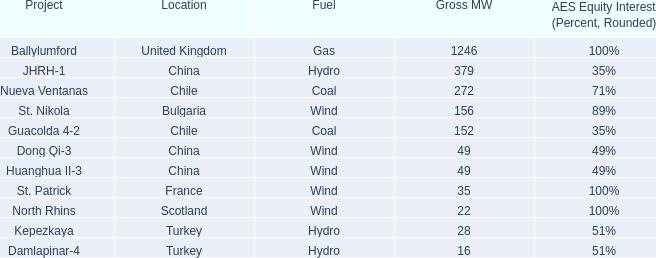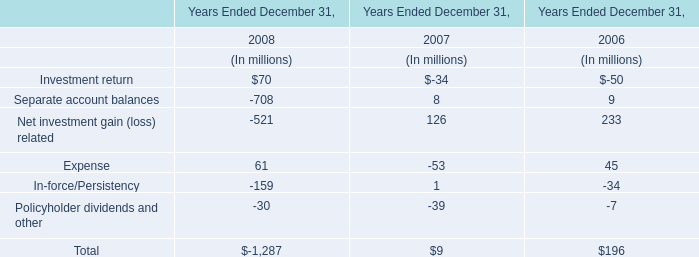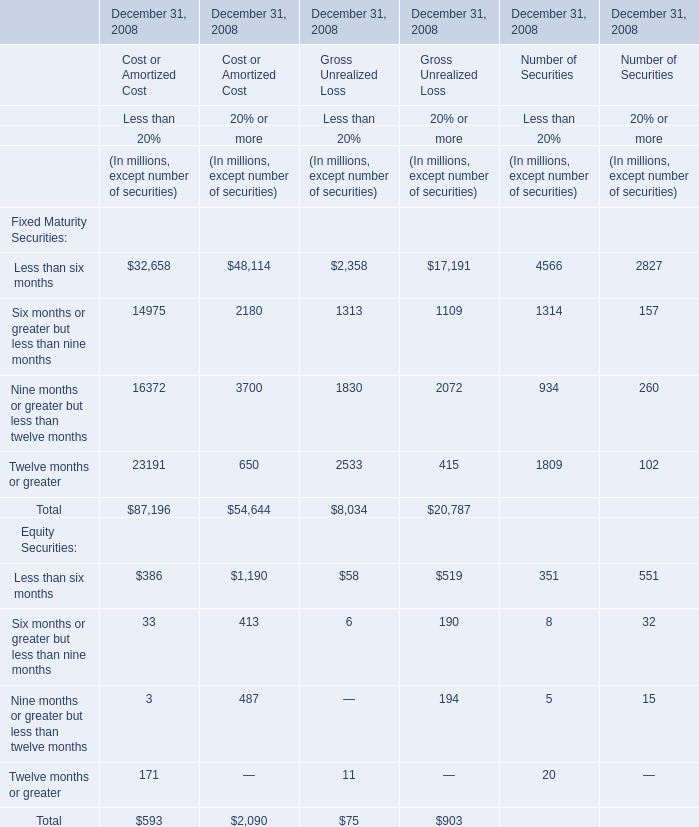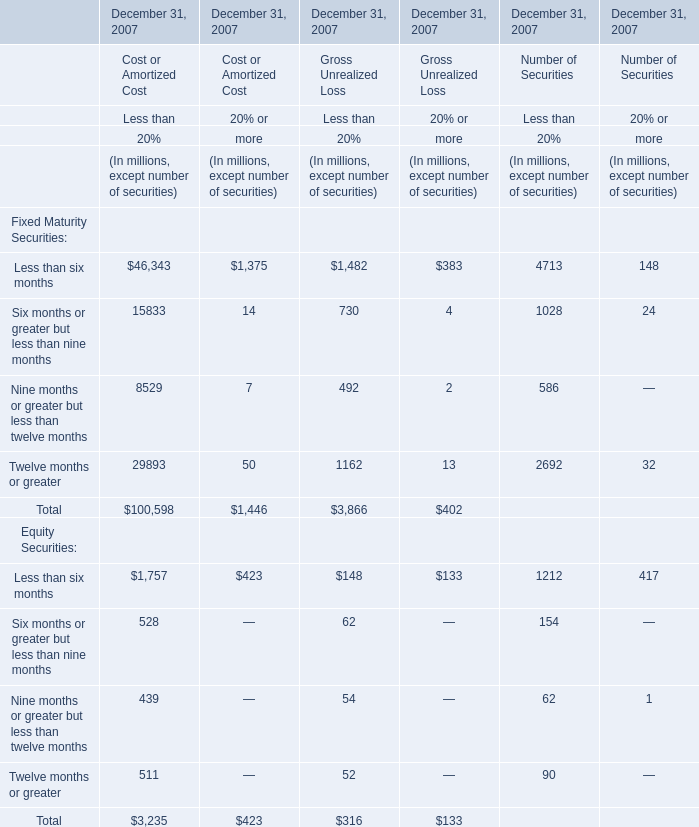What's the value of the Gross Unrealized Loss for the Fixed Maturity Securities for Twelve months or greater in terms of Less than 20% at December 31, 2007? (in million) 
Answer: 1162. 